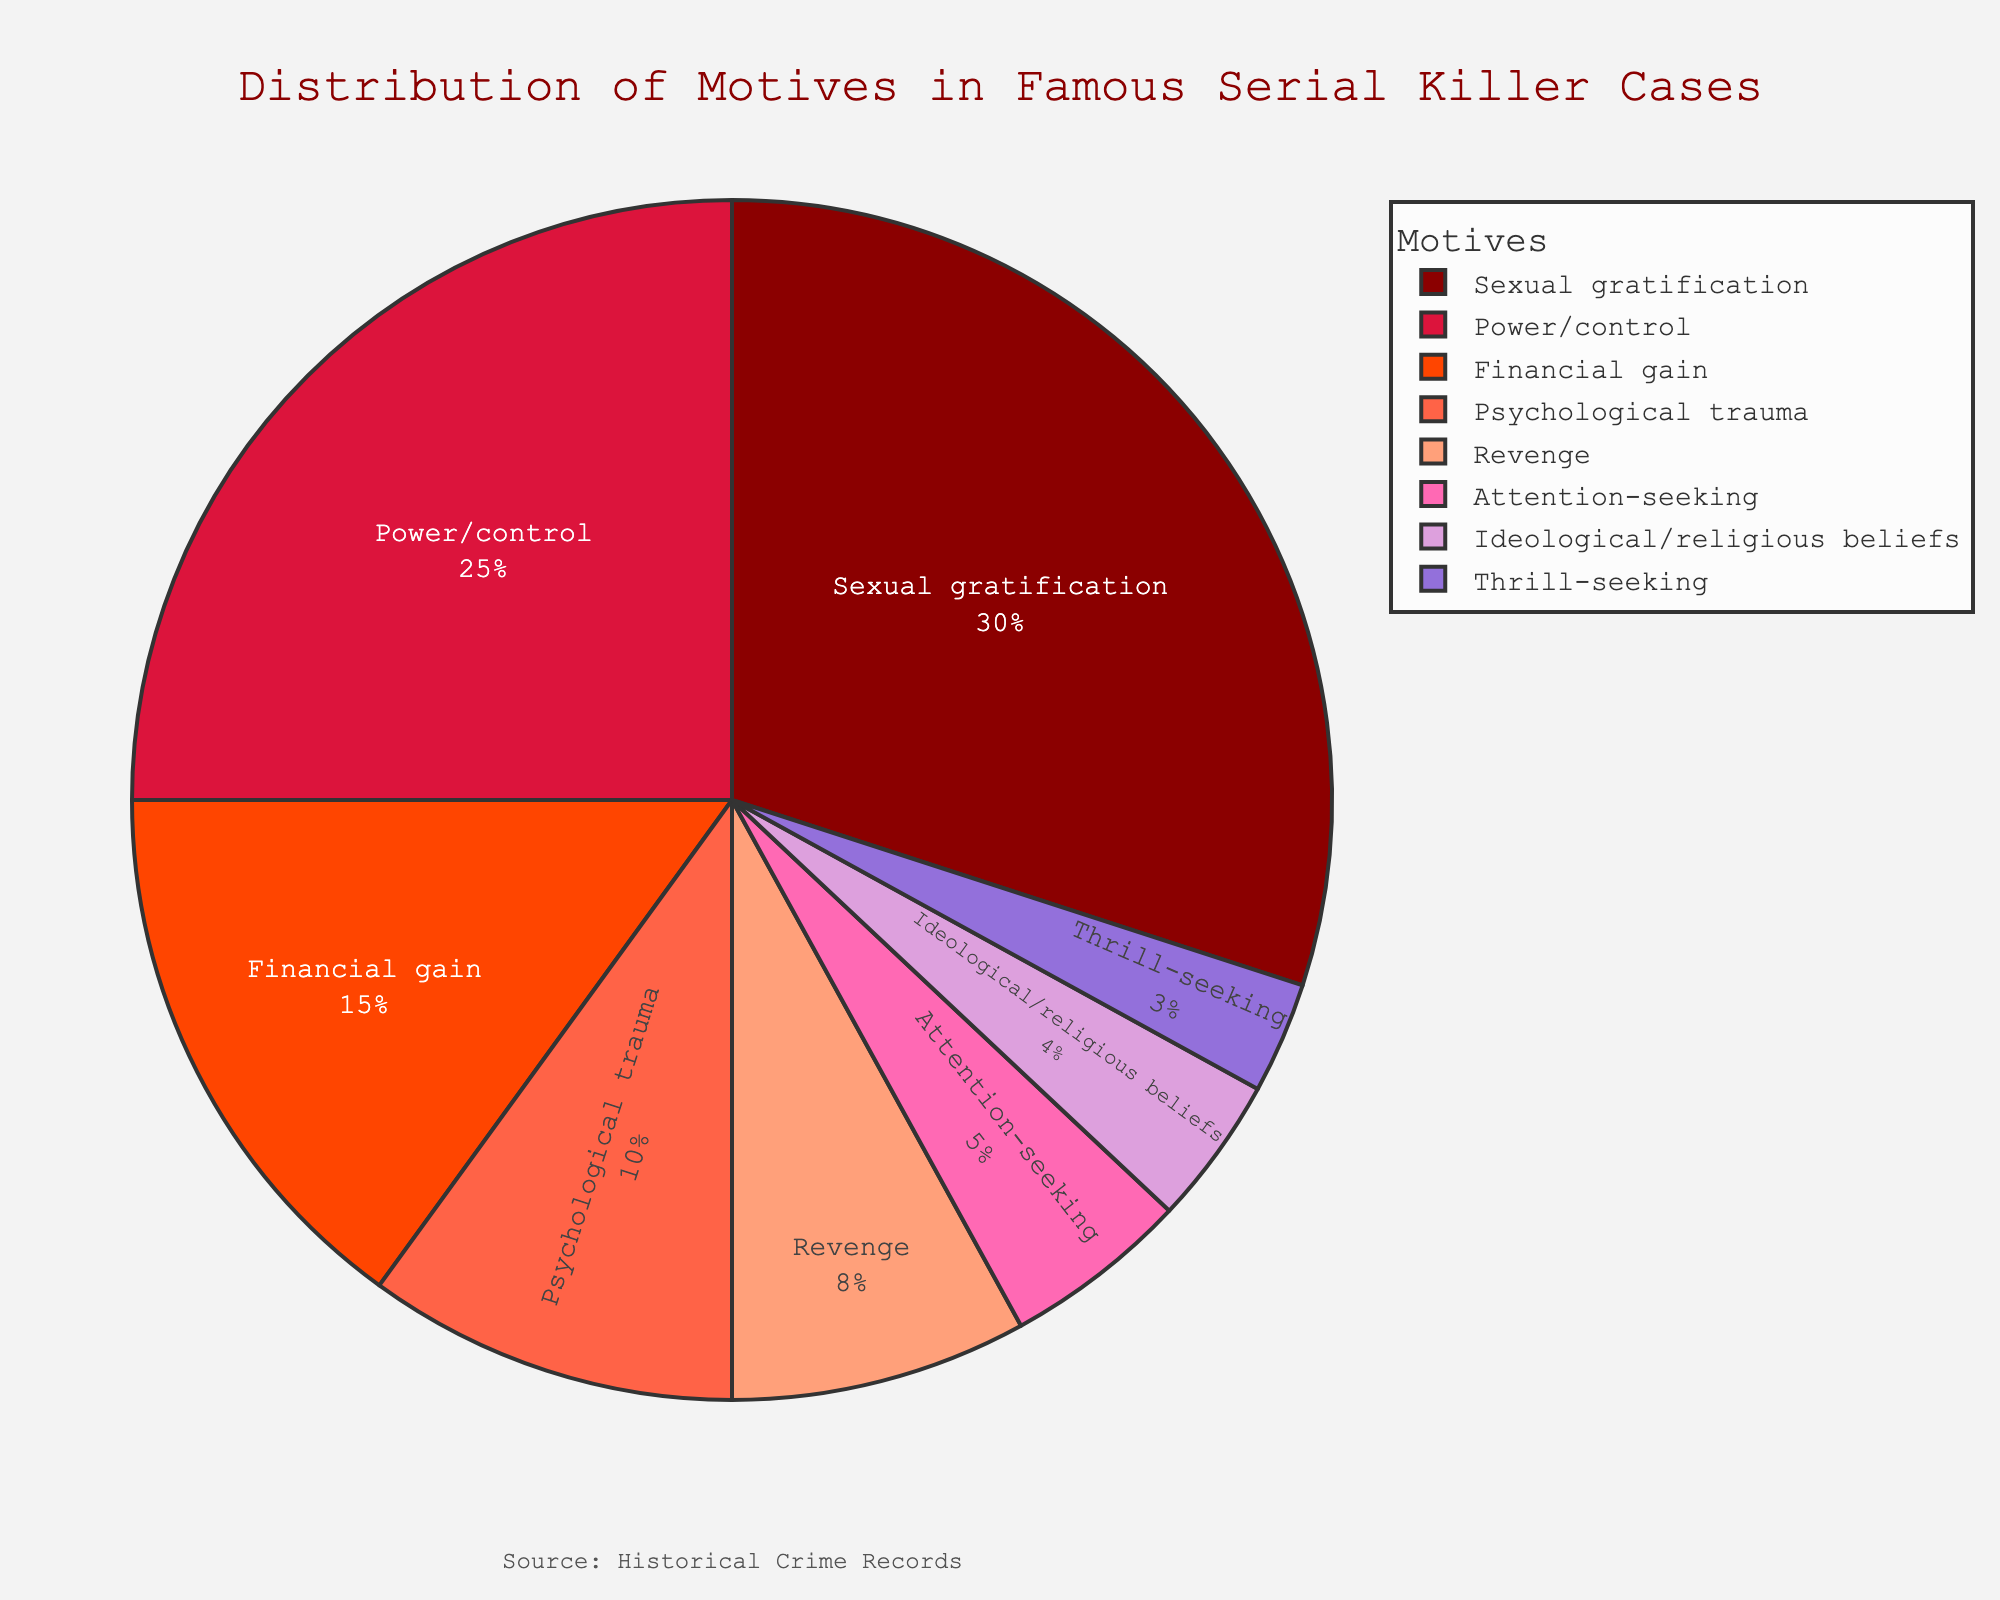What motive has the highest percentage? Look at the motive with the largest portion of the pie chart. The segment labeled "Sexual gratification" occupies the largest area.
Answer: Sexual gratification What is the combined percentage of motives related to psychological trauma and revenge? Calculate the sum of the percentages for psychological trauma (10%) and revenge (8%). 10 + 8 = 18.
Answer: 18% Which motive is represented by the smallest portion of the pie chart? Identify the motive with the smallest segment. The smallest segment is labeled "Thrill-seeking" with 3%.
Answer: Thrill-seeking How much larger is the percentage of motives driven by power/control compared to financial gain? Subtract the percentage for financial gain (15%) from the percentage for power/control (25%). 25 - 15 = 10.
Answer: 10% Which motive colors appear next to each other in the pie chart? Observing the adjacent colored sections: "#8B0000" for Financial gain and "#DC143C" for Sexual gratification. "#FF4500" for Power/control and "#FF6347" for Psychological trauma. "#FFA07A" for Revenge and "#FF69B4" for Attention-seeking. "#DDA0DD" for Ideological/religious beliefs and "#9370DB" for Thrill-seeking.
Answer: Various adjacent colored motives like Financial gain and Sexual gratification What is the cumulative percentage of the top three motives? Sum the percentages of the top three motives: Sexual gratification (30%), Power/control (25%), and Financial gain (15%). 30 + 25 + 15 = 70.
Answer: 70% How does the percentage of attention-seeking compare to that of ideological/religious beliefs? Compare the percentages of attention-seeking (5%) and ideological/religious beliefs (4%). 5 is greater than 4.
Answer: Attention-seeking is higher What is the average percentage of psychological trauma, revenge, and attention-seeking motives? Calculate the average of psychological trauma (10%), revenge (8%), and attention-seeking (5%): (10 + 8 + 5) / 3 = 7.67.
Answer: 7.67% What is the total percentage of lesser common motives (Attention-seeking, Ideological/religious beliefs, Thrill-seeking)? Sum the percentages of these lesser common motives: Attention-seeking (5%), Ideological/religious beliefs (4%), Thrill-seeking (3%). 5 + 4 + 3 = 12.
Answer: 12% Which motive occupies a red-colored segment in the pie chart? Referring to the color, "Red" is associated with "#8B0000" for Financial gain, and "#DC143C" for Sexual gratification. Considering the darker shade: The motive with the "#DC143C" color is Sexual gratification.
Answer: Sexual gratification 